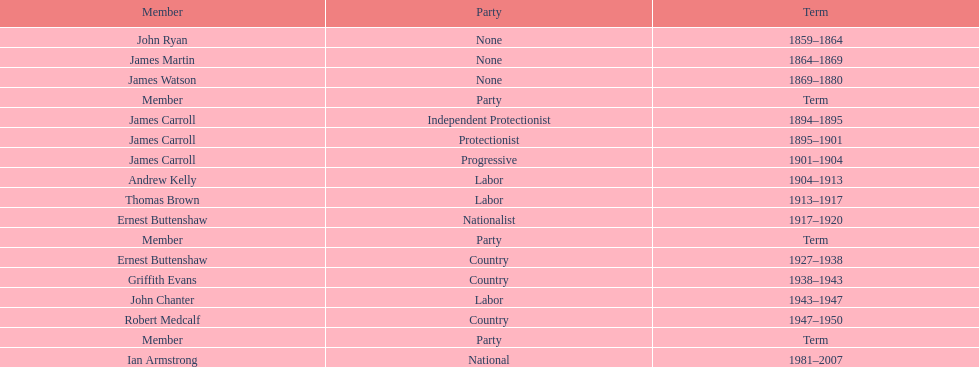Which participant of the second iteration of the lachlan was also a nationalist? Ernest Buttenshaw. 